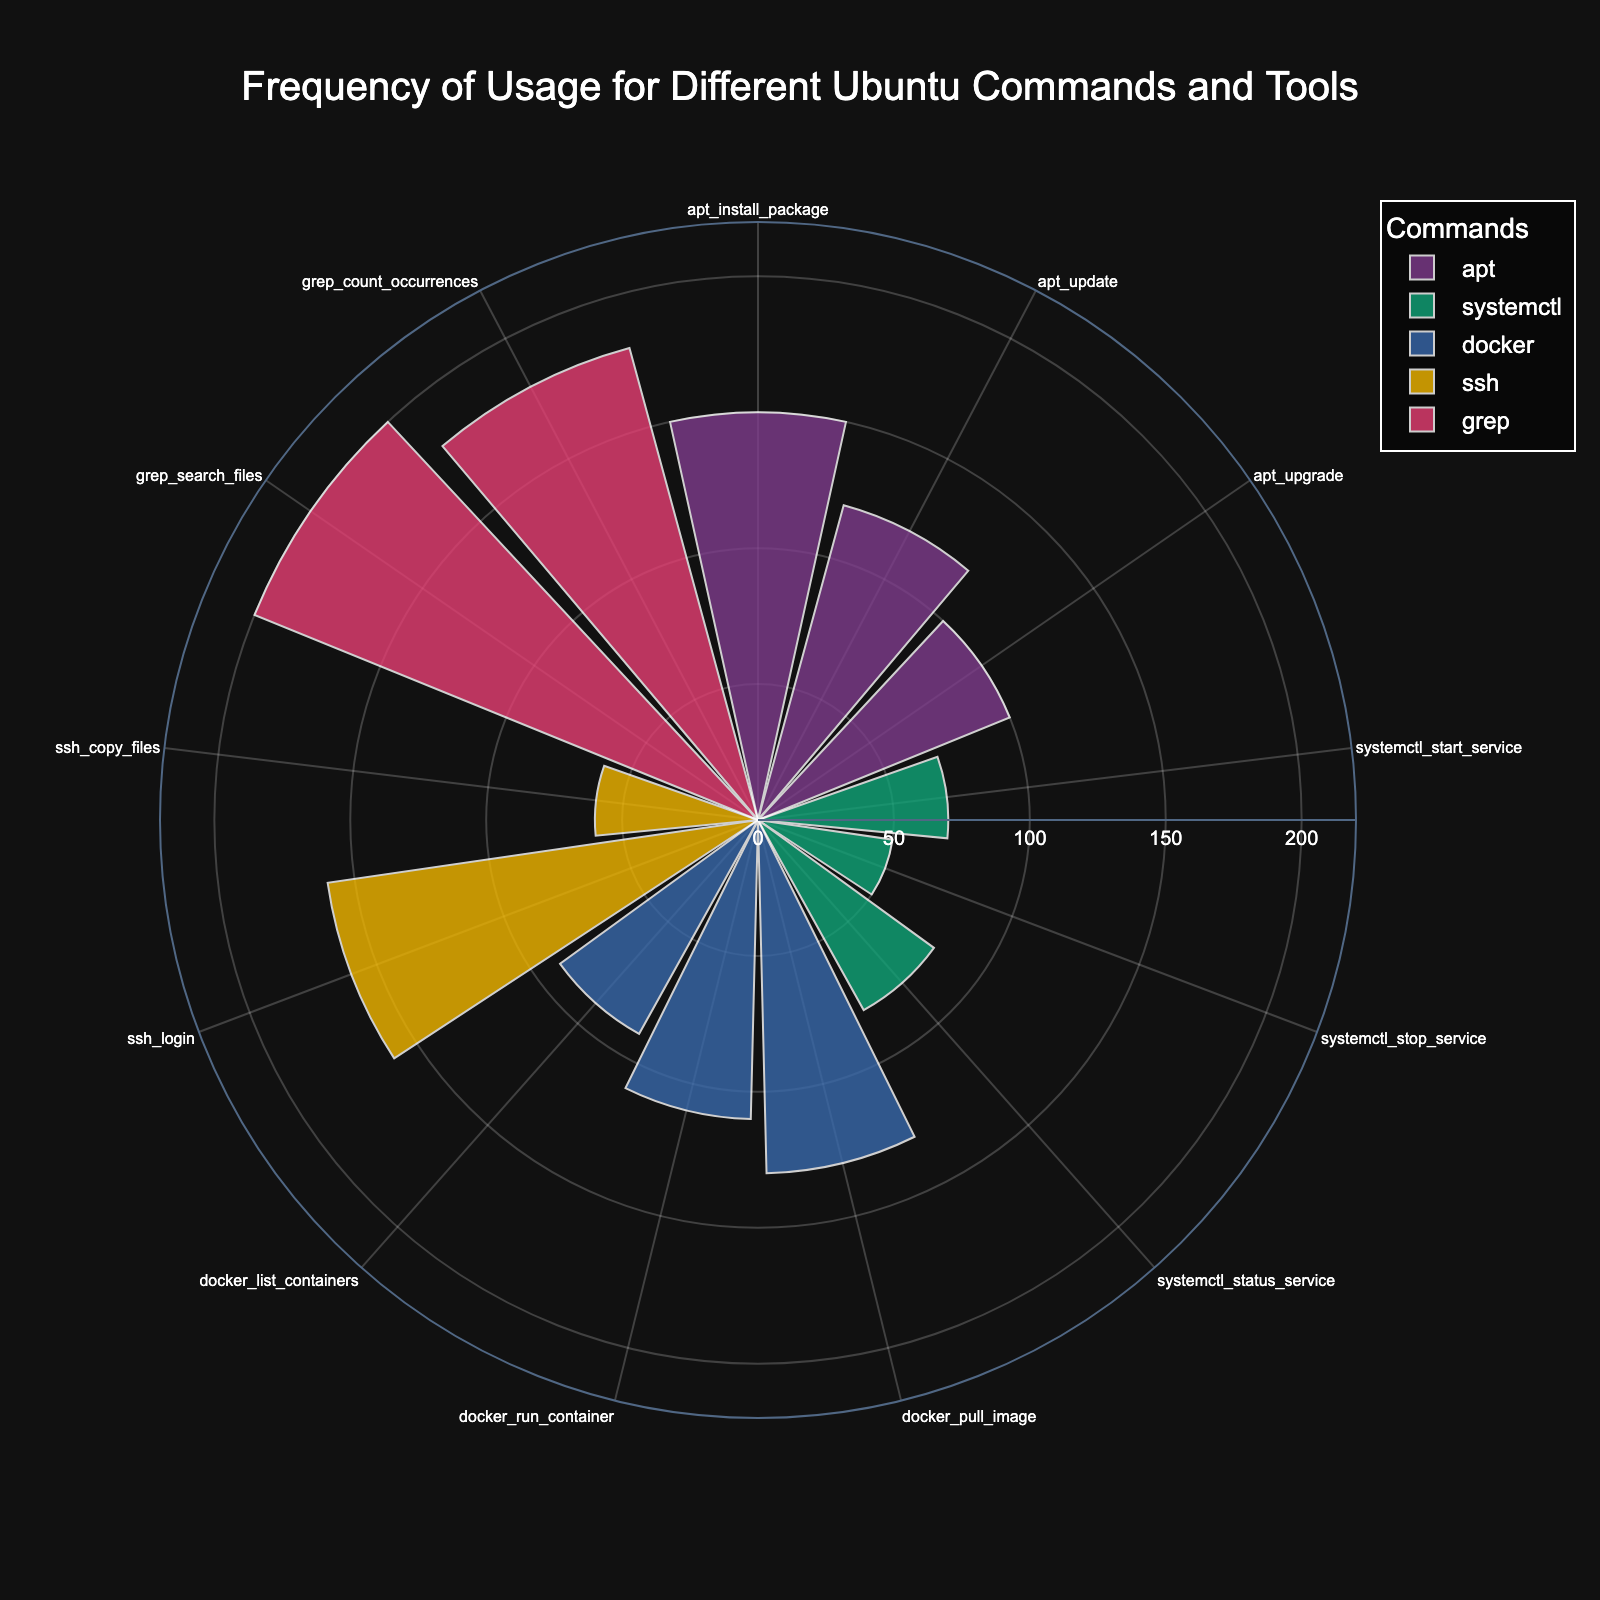What's the title of the chart? The title is generally displayed at the top of a chart and provides a brief summary of the information being presented. In the given figure, the title is "Frequency of Usage for Different Ubuntu Commands and Tools".
Answer: Frequency of Usage for Different Ubuntu Commands and Tools Which command and action have the highest count? To find the highest count, look for the bar extending the furthest from the center. In this case, "grep_search_files" has the highest count with 200.
Answer: grep_search_files How many different commands are represented in the chart? The different commands can be identified through distinct colors or the legend. According to the legend: apt, systemctl, docker, ssh, and grep are represented.
Answer: 5 What is the combined count of all actions under the 'apt' command? Sum the counts of the actions under 'apt': install_package (150), update (120), and upgrade (100). The total is 150 + 120 + 100 = 370.
Answer: 370 Which action under the 'docker' command has the lowest count? Check the lengths of the bars for 'docker' related actions. The shortest bar for 'docker' actions is for "docker_list_containers" with a count of 90.
Answer: docker_list_containers What is the difference in count between 'ssh_login' and 'docker_pull_image'? Identify the counts for 'ssh_login' (160) and 'docker_pull_image' (130), then subtract the latter from the former: 160 - 130 = 30.
Answer: 30 Are there any commands with an action count exactly at 150? If so, which ones? Look at the bars reaching the 150 mark. "apt_install_package" has a count of 150.
Answer: apt_install_package Which command has the most balanced usage among its actions? Compare the differences between the counts of actions within each command. "apt" has counts of 150, 120, and 100; "systemctl" has 70, 50, and 80; "docker" has 130, 110, and 90. The balance can be checked by the range (max - min). "apt" has the least range of 50 (150-100), making it the most balanced.
Answer: apt What is the average count of 'grep' related actions? Sum the counts of 'grep_search_files' (200) and 'grep_count_occurrences' (180) and divide by the number of actions: (200 + 180) / 2 = 190.
Answer: 190 Does 'ssh_copy_files' have a count greater than 'systemctl_stop_service'? Look at the counts for 'ssh_copy_files' (60) and 'systemctl_stop_service' (50), and compare them.
Answer: Yes 